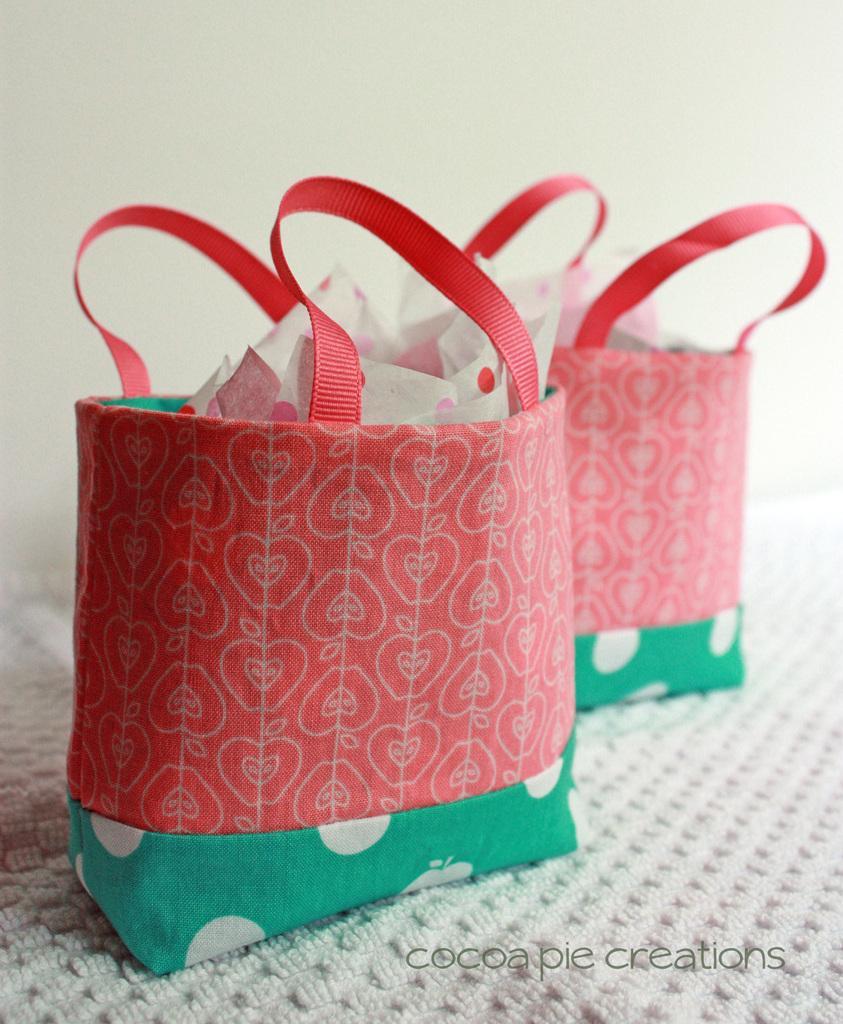In one or two sentences, can you explain what this image depicts? In this picture there are two bag. The bags are in red and green color, in the bag there are some items. Under the bag there is a white mat. Behind the bag there is a white wall. 